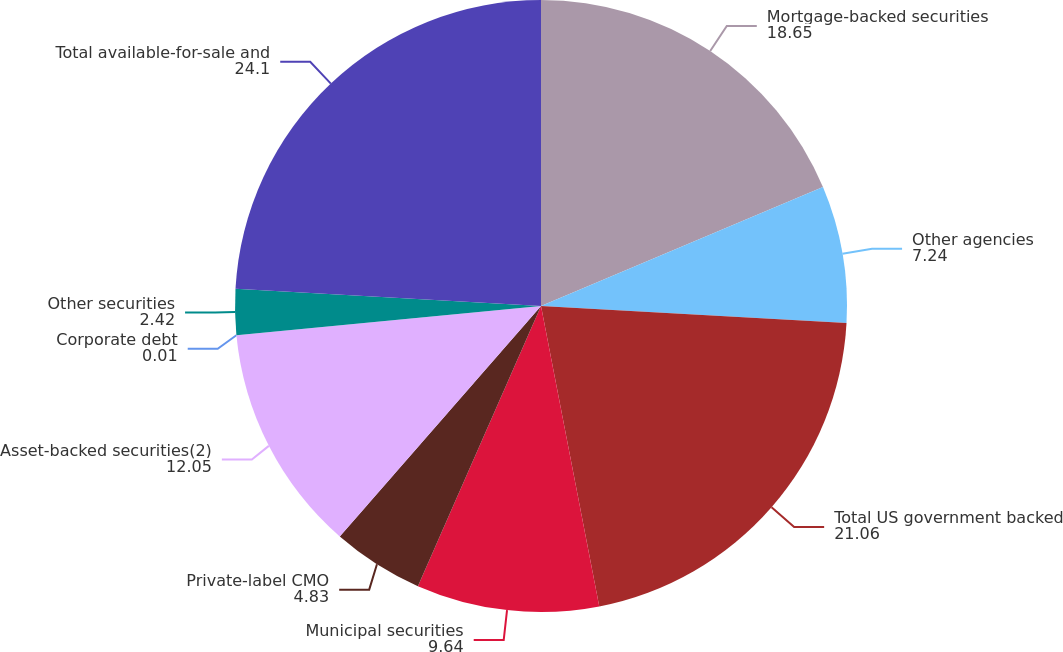<chart> <loc_0><loc_0><loc_500><loc_500><pie_chart><fcel>Mortgage-backed securities<fcel>Other agencies<fcel>Total US government backed<fcel>Municipal securities<fcel>Private-label CMO<fcel>Asset-backed securities(2)<fcel>Corporate debt<fcel>Other securities<fcel>Total available-for-sale and<nl><fcel>18.65%<fcel>7.24%<fcel>21.06%<fcel>9.64%<fcel>4.83%<fcel>12.05%<fcel>0.01%<fcel>2.42%<fcel>24.1%<nl></chart> 